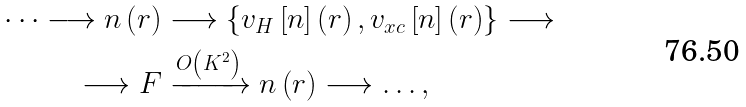<formula> <loc_0><loc_0><loc_500><loc_500>\dots \longrightarrow n \left ( r \right ) & \longrightarrow \left \{ v _ { H } \left [ n \right ] \left ( r \right ) , v _ { x c } \left [ n \right ] \left ( r \right ) \right \} \longrightarrow \\ \longrightarrow F & \xrightarrow { O \left ( K ^ { 2 } \right ) } n \left ( r \right ) \longrightarrow \dots ,</formula> 